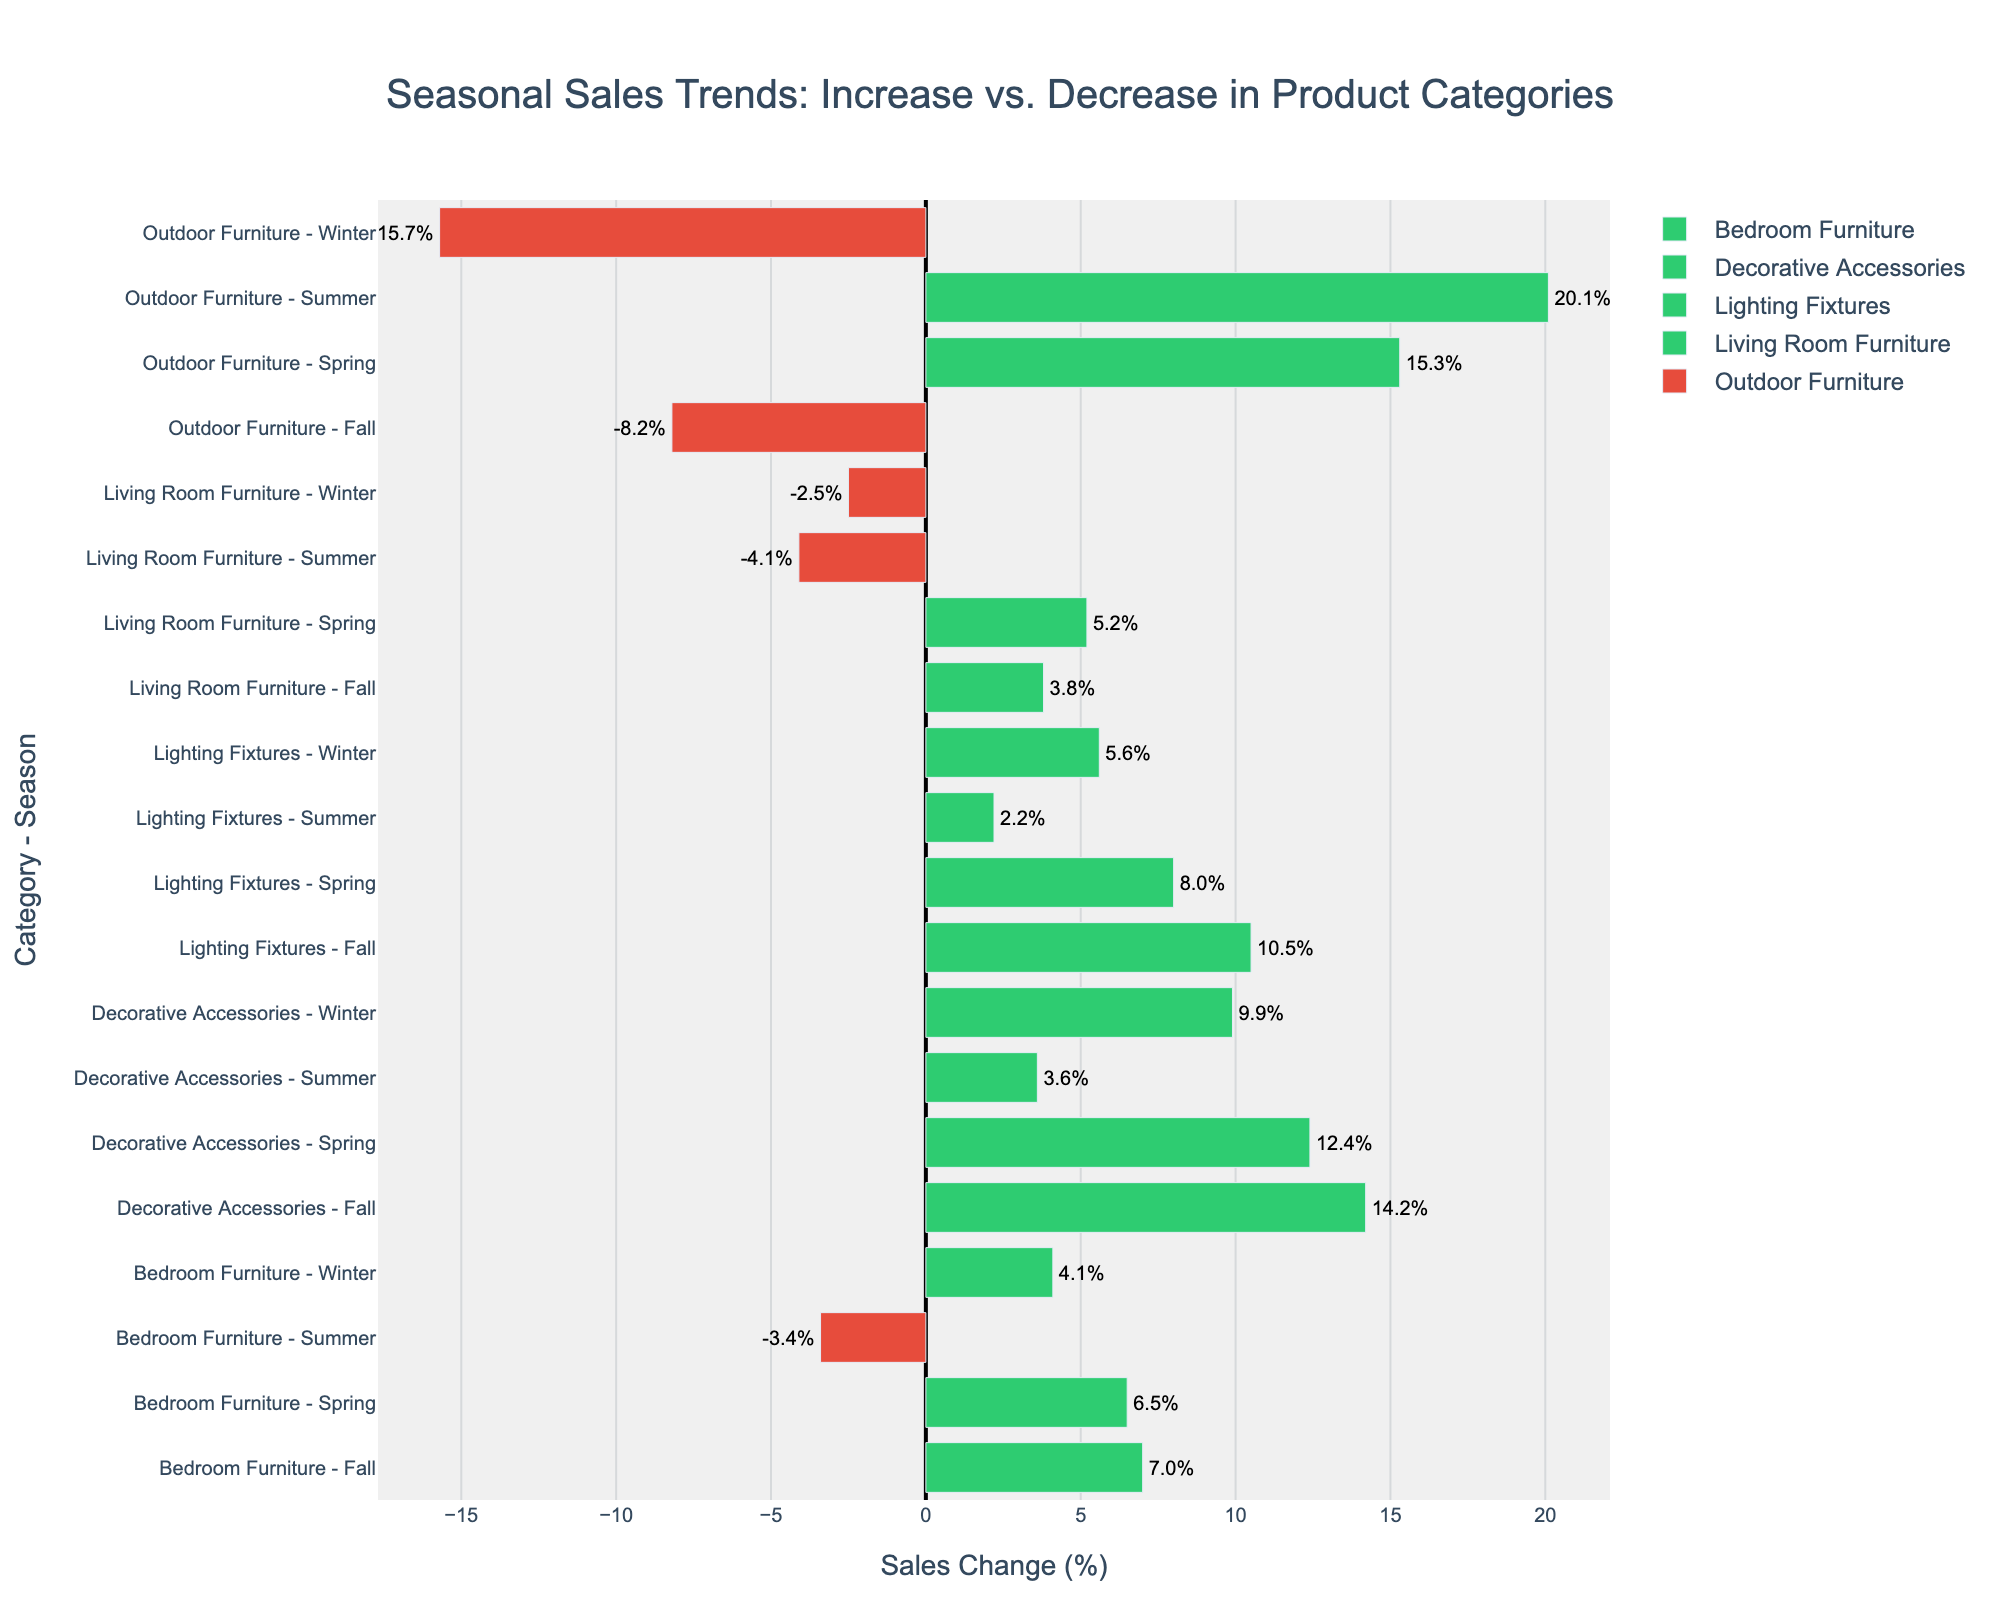What is the sales change percentage for Living Room Furniture in Summer? The figure has a bar for Living Room Furniture in Summer colored red, indicating a sales decrease. The exact value next to this bar is -4.1%.
Answer: -4.1% Which category had the highest sales increase in Spring? By examining the green bars for Spring, Outdoor Furniture shows the highest sales increase, with a percentage of 15.3%.
Answer: Outdoor Furniture How does the Winter sales change for Bedroom Furniture compare to the Winter sales change for Living Room Furniture? The Winter sales change for Bedroom Furniture is 4.1% (green bar), while for Living Room Furniture, it is -2.5% (red bar). Bedroom Furniture has a higher sales change.
Answer: Bedroom Furniture has a higher sales change What is the average sales change percent for Decorative Accessories across all seasons? Summing up the sales change percentages for Decorative Accessories in Spring (12.4%), Summer (3.6%), Fall (14.2%), and Winter (9.9%) and then dividing by 4: (12.4 + 3.6 + 14.2 + 9.9) / 4 = 10.025%.
Answer: 10.025% Which season had the largest sales decrease for Outdoor Furniture? The red bar for Winter under Outdoor Furniture indicates a sales change of -15.7%, the largest decrease for this category.
Answer: Winter Compare the sales changes for Lighting Fixtures in Spring and Fall and determine the difference. The green bars show sales changes for Lighting Fixtures as 8.0% in Spring and 10.5% in Fall. The difference is 10.5% - 8.0% = 2.5%.
Answer: 2.5% What is the combined sales change percentage for Bedroom Furniture in Spring and Fall? Adding the sales change percentages of Bedroom Furniture for Spring (6.5%) and Fall (7.0%): 6.5% + 7.0% = 13.5%.
Answer: 13.5% Which category experienced a consistent sales increase in all the seasons? By looking at the green bars, Decorative Accessories have all positive sales changes in Spring (12.4%), Summer (3.6%), Fall (14.2%), and Winter (9.9%).
Answer: Decorative Accessories What was the total sales change percentage for Living Room Furniture across all seasons? Adding the sales change percentages for Living Room Furniture: 5.2% (Spring), -4.1% (Summer), 3.8% (Fall), -2.5% (Winter) gives 5.2 - 4.1 + 3.8 - 2.5 = 2.4%.
Answer: 2.4% How many categories faced a sales decrease in Fall? The red bars for Fall show decreases in Living Room Furniture (-8.2%) and Outdoor Furniture (-8.2%), so 2 categories faced a sales decrease.
Answer: 2 categories 